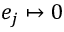Convert formula to latex. <formula><loc_0><loc_0><loc_500><loc_500>e _ { j } \mapsto 0</formula> 